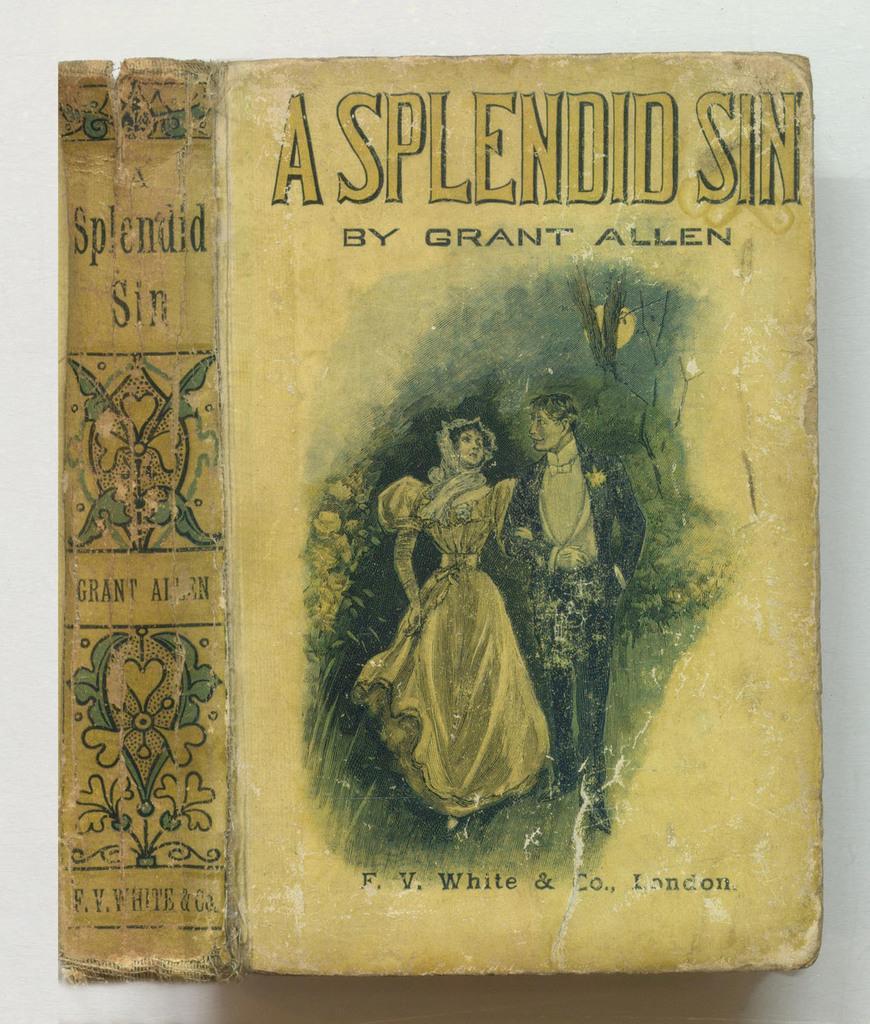<image>
Present a compact description of the photo's key features. A book called the Splendid Sin by Grant Allen 